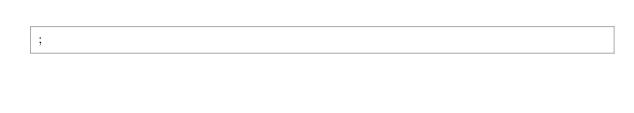<code> <loc_0><loc_0><loc_500><loc_500><_SQL_>;
</code> 